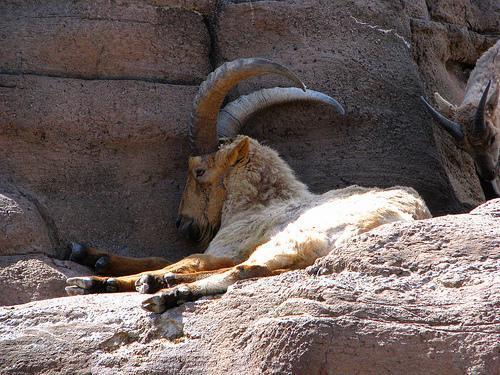How many animals are in this picture?
Give a very brief answer. 2. 